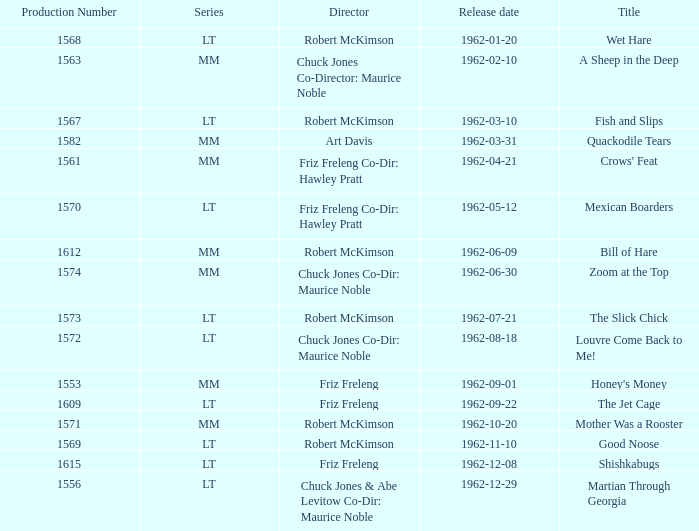What is Crows' Feat's production number? 1561.0. 